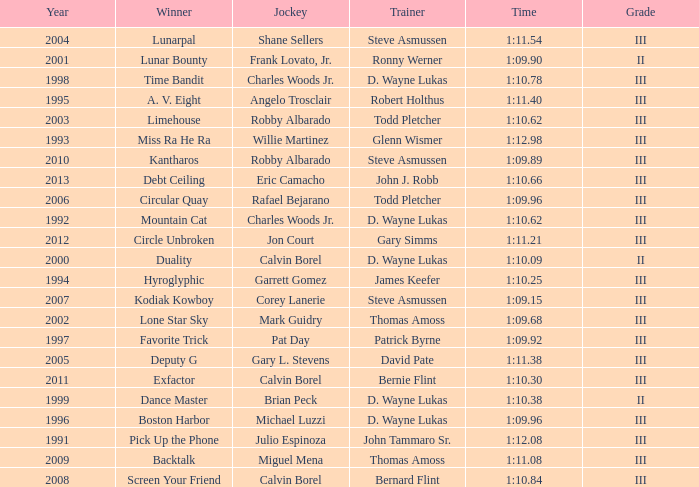What was the time for Screen Your Friend? 1:10.84. 